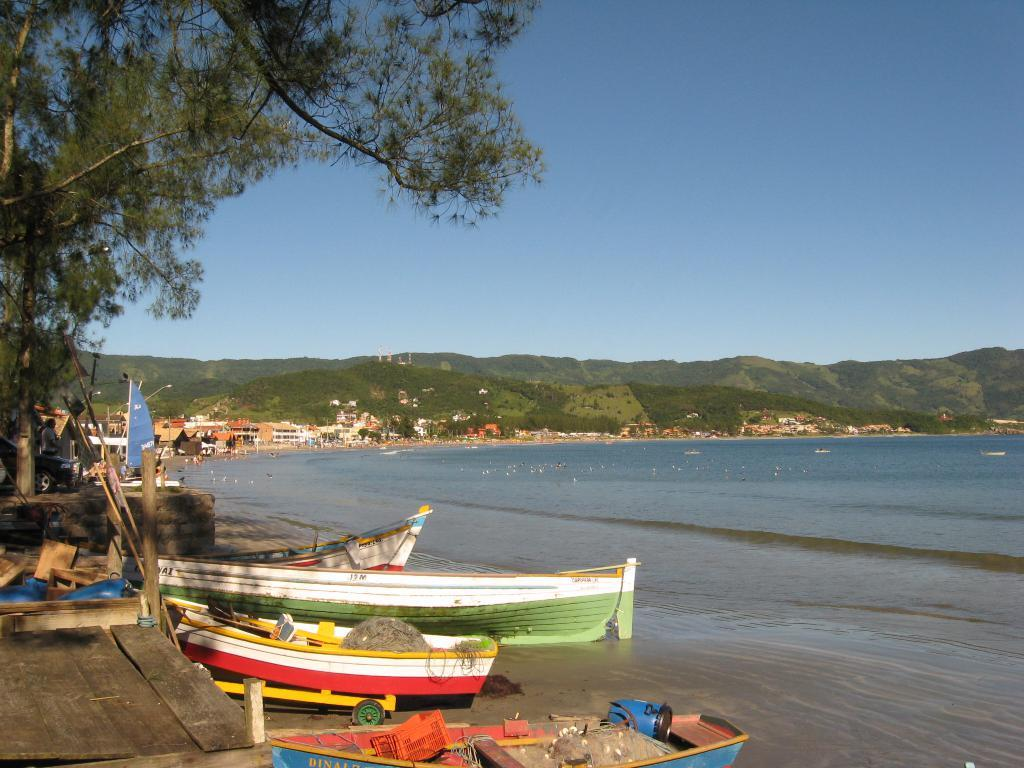What type of location is depicted in the image? The image depicts a seaside location. What can be seen near the sea in the image? There are boats near the sea in the image. What is located on the left side of the image? There is a big tree on the left side of the image. What structures are visible behind the sea? There are houses visible behind the sea in the image. What is visible in the background of the image? There are mountains in the background of the image. What is the value of the country in the image? There is no country present in the image, so it is not possible to determine its value. 